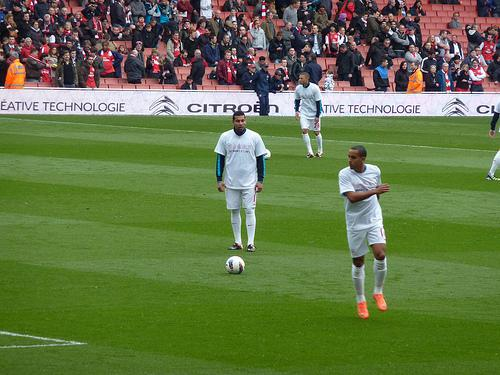Question: what color shoes is the player wearing closest?
Choices:
A. The player's wearing blue shoes.
B. Black ones.
C. The player is wearing green shoes.
D. The player is wearing orange shoes.
Answer with the letter. Answer: D Question: where is this photo taken?
Choices:
A. In a soccer field.
B. In a football field.
C. At a hockey rink.
D. In a baseball field.
Answer with the letter. Answer: A Question: when is this taken?
Choices:
A. During the daytime hours.
B. During the night.
C. At sunset.
D. At sunrise.
Answer with the letter. Answer: A Question: what kind of game is this?
Choices:
A. It is a soccer game.
B. It is a hockey game.
C. It is a baseball game.
D. It is a football game.
Answer with the letter. Answer: A Question: what color arm bands is the player on back wearing?
Choices:
A. Red.
B. They are blue armbands.
C. Pink.
D. White.
Answer with the letter. Answer: B Question: who is the man standing in the back?
Choices:
A. The man in the back it the coach.
B. The man in the back is a player's  father.
C. The man in the back is a referee.
D. The man in the back is a spectator.
Answer with the letter. Answer: C 